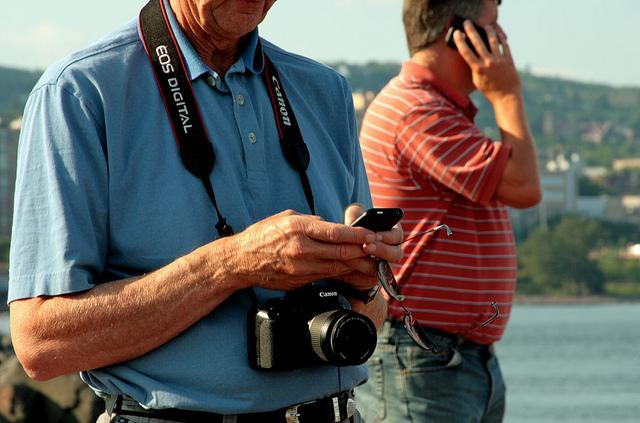What does the man do with the object around his neck? Please explain your reasoning. take photos. The man is taking photos. 